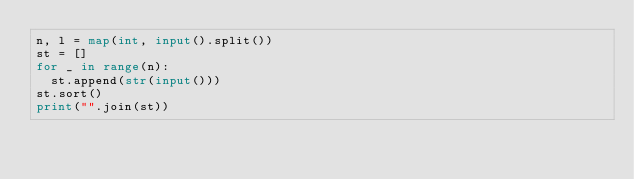Convert code to text. <code><loc_0><loc_0><loc_500><loc_500><_Python_>n, l = map(int, input().split())
st = []
for _ in range(n):
  st.append(str(input()))
st.sort()
print("".join(st))</code> 